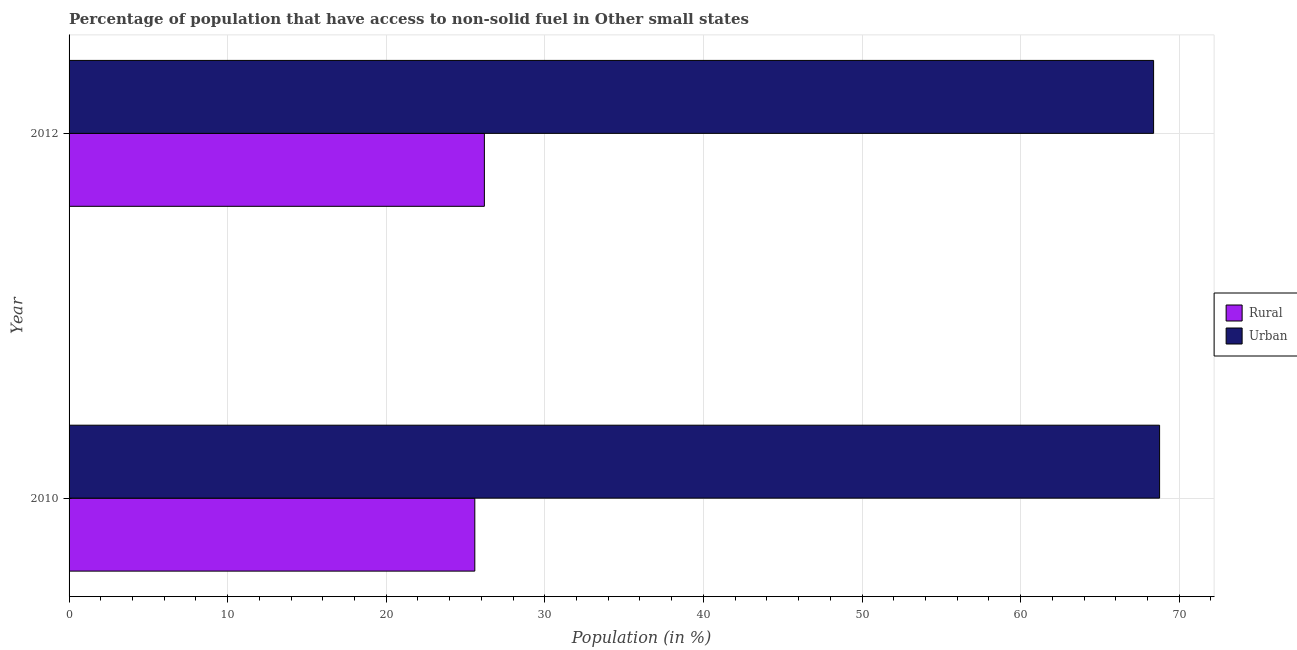How many different coloured bars are there?
Offer a very short reply. 2. How many groups of bars are there?
Ensure brevity in your answer.  2. Are the number of bars per tick equal to the number of legend labels?
Provide a short and direct response. Yes. Are the number of bars on each tick of the Y-axis equal?
Offer a very short reply. Yes. How many bars are there on the 2nd tick from the top?
Provide a short and direct response. 2. What is the label of the 2nd group of bars from the top?
Keep it short and to the point. 2010. In how many cases, is the number of bars for a given year not equal to the number of legend labels?
Keep it short and to the point. 0. What is the rural population in 2010?
Provide a short and direct response. 25.58. Across all years, what is the maximum rural population?
Offer a very short reply. 26.19. Across all years, what is the minimum rural population?
Your answer should be very brief. 25.58. In which year was the urban population minimum?
Offer a very short reply. 2012. What is the total rural population in the graph?
Provide a succinct answer. 51.77. What is the difference between the rural population in 2010 and that in 2012?
Offer a terse response. -0.6. What is the difference between the urban population in 2010 and the rural population in 2012?
Offer a very short reply. 42.58. What is the average rural population per year?
Give a very brief answer. 25.89. In the year 2010, what is the difference between the urban population and rural population?
Offer a terse response. 43.18. In how many years, is the rural population greater than 44 %?
Give a very brief answer. 0. Is the urban population in 2010 less than that in 2012?
Offer a very short reply. No. In how many years, is the urban population greater than the average urban population taken over all years?
Provide a short and direct response. 1. What does the 2nd bar from the top in 2010 represents?
Ensure brevity in your answer.  Rural. What does the 2nd bar from the bottom in 2010 represents?
Your answer should be very brief. Urban. Are all the bars in the graph horizontal?
Provide a succinct answer. Yes. Does the graph contain grids?
Offer a very short reply. Yes. Where does the legend appear in the graph?
Your answer should be compact. Center right. How many legend labels are there?
Your answer should be compact. 2. How are the legend labels stacked?
Keep it short and to the point. Vertical. What is the title of the graph?
Offer a very short reply. Percentage of population that have access to non-solid fuel in Other small states. Does "Broad money growth" appear as one of the legend labels in the graph?
Your answer should be compact. No. What is the label or title of the Y-axis?
Provide a short and direct response. Year. What is the Population (in %) of Rural in 2010?
Ensure brevity in your answer.  25.58. What is the Population (in %) of Urban in 2010?
Ensure brevity in your answer.  68.77. What is the Population (in %) of Rural in 2012?
Give a very brief answer. 26.19. What is the Population (in %) in Urban in 2012?
Your answer should be compact. 68.39. Across all years, what is the maximum Population (in %) of Rural?
Your answer should be compact. 26.19. Across all years, what is the maximum Population (in %) in Urban?
Make the answer very short. 68.77. Across all years, what is the minimum Population (in %) in Rural?
Offer a terse response. 25.58. Across all years, what is the minimum Population (in %) in Urban?
Ensure brevity in your answer.  68.39. What is the total Population (in %) of Rural in the graph?
Offer a very short reply. 51.77. What is the total Population (in %) in Urban in the graph?
Give a very brief answer. 137.15. What is the difference between the Population (in %) of Rural in 2010 and that in 2012?
Your answer should be compact. -0.6. What is the difference between the Population (in %) in Urban in 2010 and that in 2012?
Make the answer very short. 0.38. What is the difference between the Population (in %) in Rural in 2010 and the Population (in %) in Urban in 2012?
Your answer should be very brief. -42.8. What is the average Population (in %) in Rural per year?
Your response must be concise. 25.89. What is the average Population (in %) in Urban per year?
Provide a succinct answer. 68.58. In the year 2010, what is the difference between the Population (in %) of Rural and Population (in %) of Urban?
Keep it short and to the point. -43.18. In the year 2012, what is the difference between the Population (in %) of Rural and Population (in %) of Urban?
Your answer should be compact. -42.2. What is the ratio of the Population (in %) of Rural in 2010 to that in 2012?
Offer a very short reply. 0.98. What is the difference between the highest and the second highest Population (in %) of Rural?
Your answer should be very brief. 0.6. What is the difference between the highest and the second highest Population (in %) in Urban?
Provide a succinct answer. 0.38. What is the difference between the highest and the lowest Population (in %) in Rural?
Offer a very short reply. 0.6. What is the difference between the highest and the lowest Population (in %) of Urban?
Ensure brevity in your answer.  0.38. 